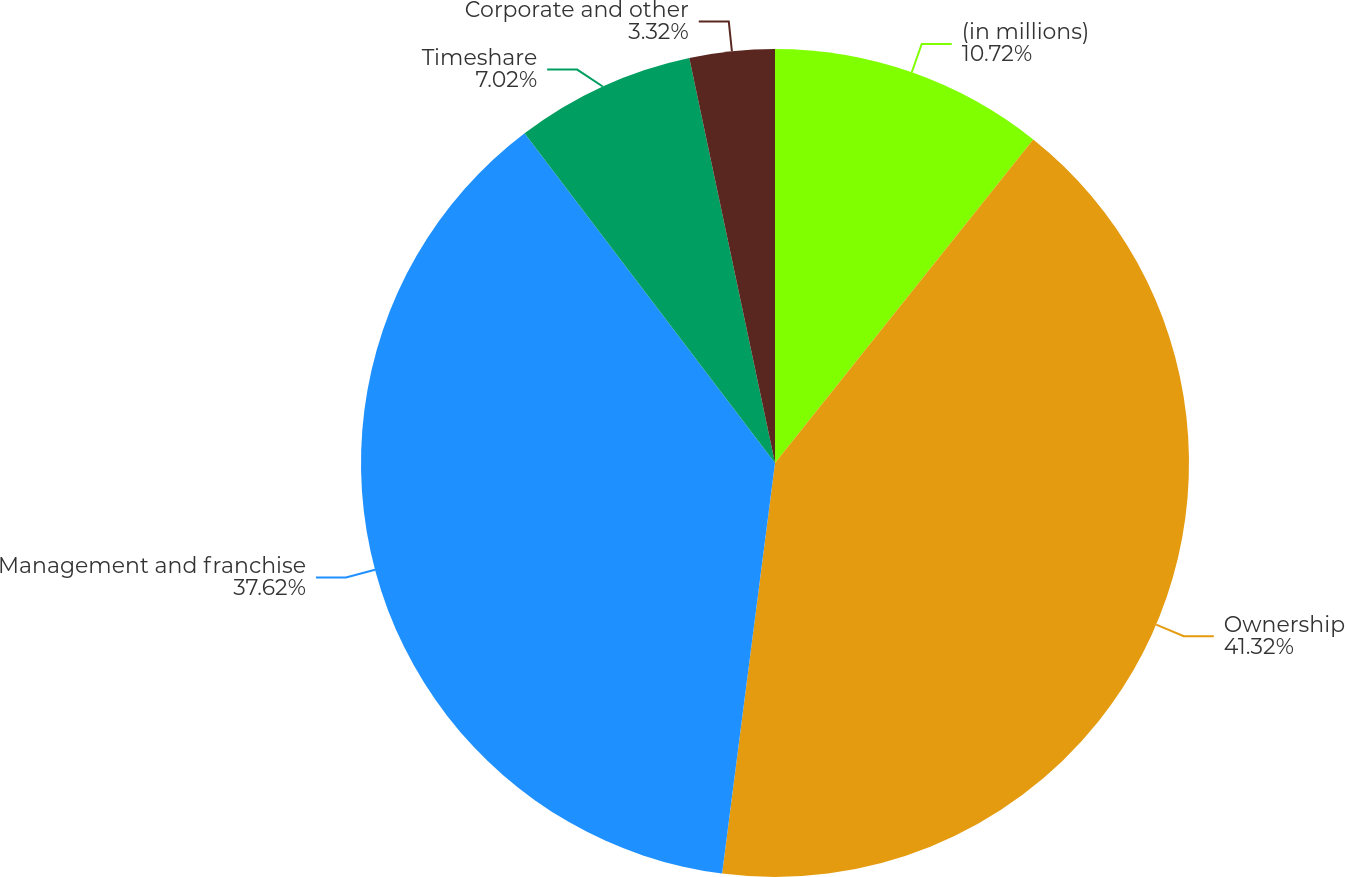Convert chart to OTSL. <chart><loc_0><loc_0><loc_500><loc_500><pie_chart><fcel>(in millions)<fcel>Ownership<fcel>Management and franchise<fcel>Timeshare<fcel>Corporate and other<nl><fcel>10.72%<fcel>41.32%<fcel>37.62%<fcel>7.02%<fcel>3.32%<nl></chart> 